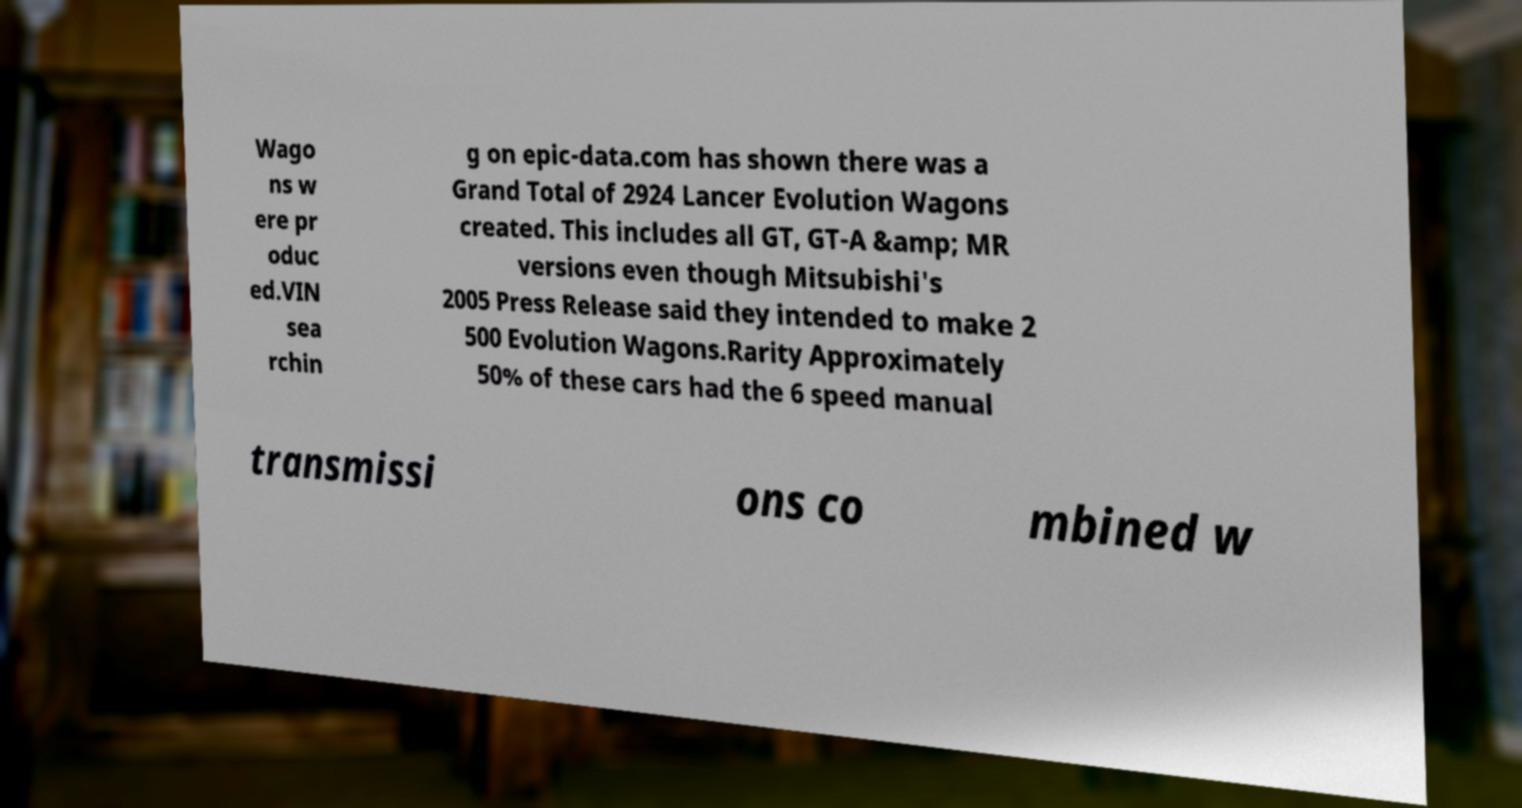Please identify and transcribe the text found in this image. Wago ns w ere pr oduc ed.VIN sea rchin g on epic-data.com has shown there was a Grand Total of 2924 Lancer Evolution Wagons created. This includes all GT, GT-A &amp; MR versions even though Mitsubishi's 2005 Press Release said they intended to make 2 500 Evolution Wagons.Rarity Approximately 50% of these cars had the 6 speed manual transmissi ons co mbined w 